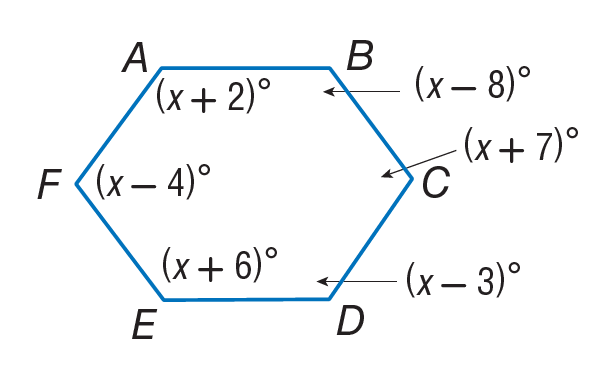Question: Find m \angle C.
Choices:
A. 112
B. 116
C. 117
D. 127
Answer with the letter. Answer: D Question: Find m \angle F.
Choices:
A. 100
B. 116
C. 127
D. 140
Answer with the letter. Answer: B Question: Find m \angle D.
Choices:
A. 117
B. 117
C. 126
D. 127
Answer with the letter. Answer: A Question: Find m \angle B.
Choices:
A. 112
B. 116
C. 122
D. 127
Answer with the letter. Answer: A Question: Find m \angle A.
Choices:
A. 112
B. 118
C. 120
D. 122
Answer with the letter. Answer: D Question: Find m \angle E.
Choices:
A. 56
B. 80
C. 126
D. 130
Answer with the letter. Answer: C 